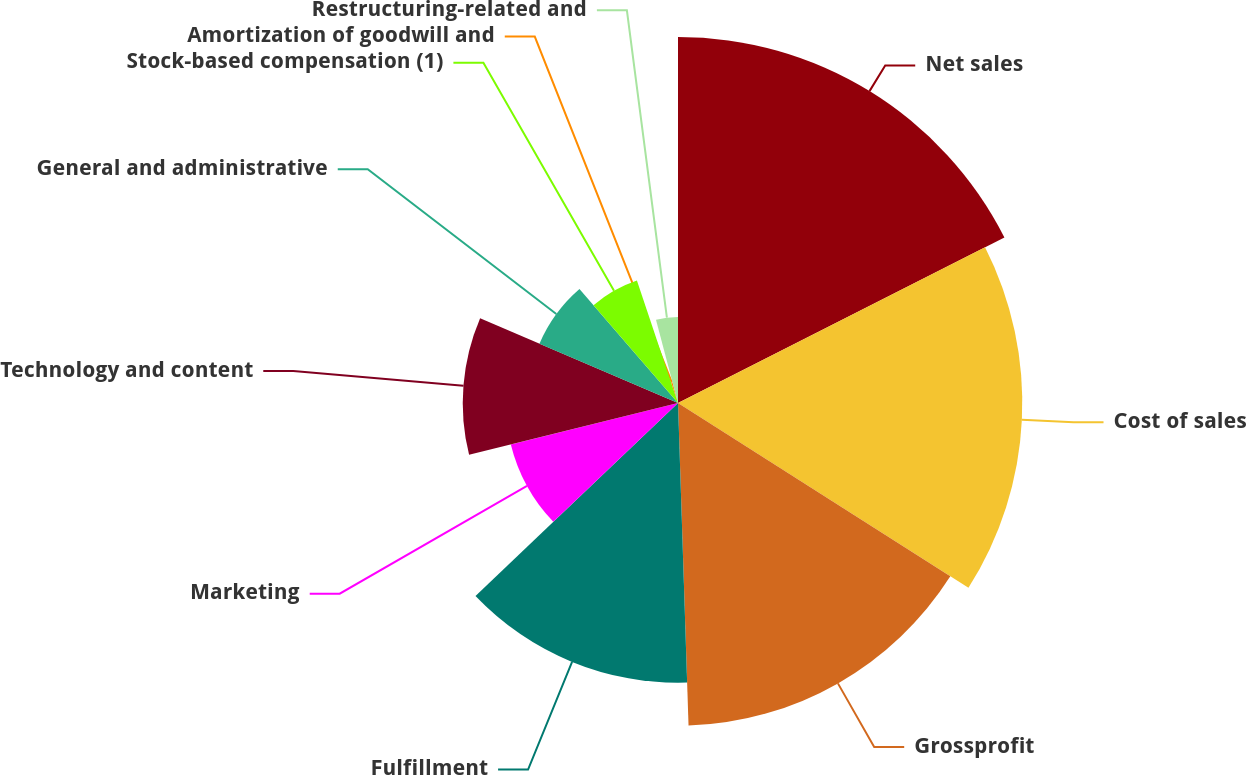Convert chart to OTSL. <chart><loc_0><loc_0><loc_500><loc_500><pie_chart><fcel>Net sales<fcel>Cost of sales<fcel>Grossprofit<fcel>Fulfillment<fcel>Marketing<fcel>Technology and content<fcel>General and administrative<fcel>Stock-based compensation (1)<fcel>Amortization of goodwill and<fcel>Restructuring-related and<nl><fcel>17.53%<fcel>16.49%<fcel>15.46%<fcel>13.4%<fcel>8.25%<fcel>10.31%<fcel>7.22%<fcel>6.19%<fcel>1.03%<fcel>4.12%<nl></chart> 